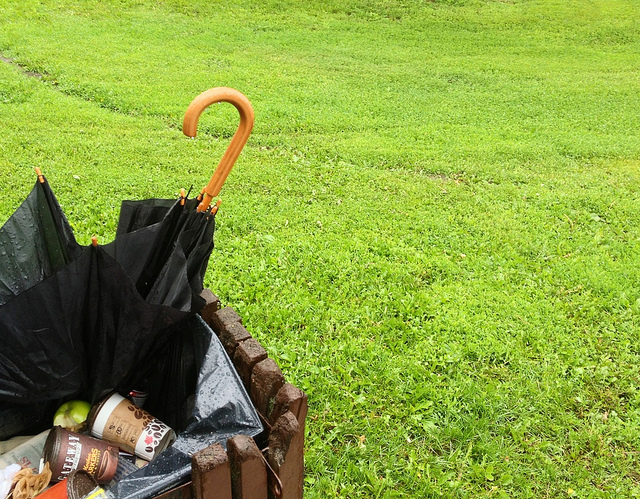Read all the text in this image. GATEWAY 